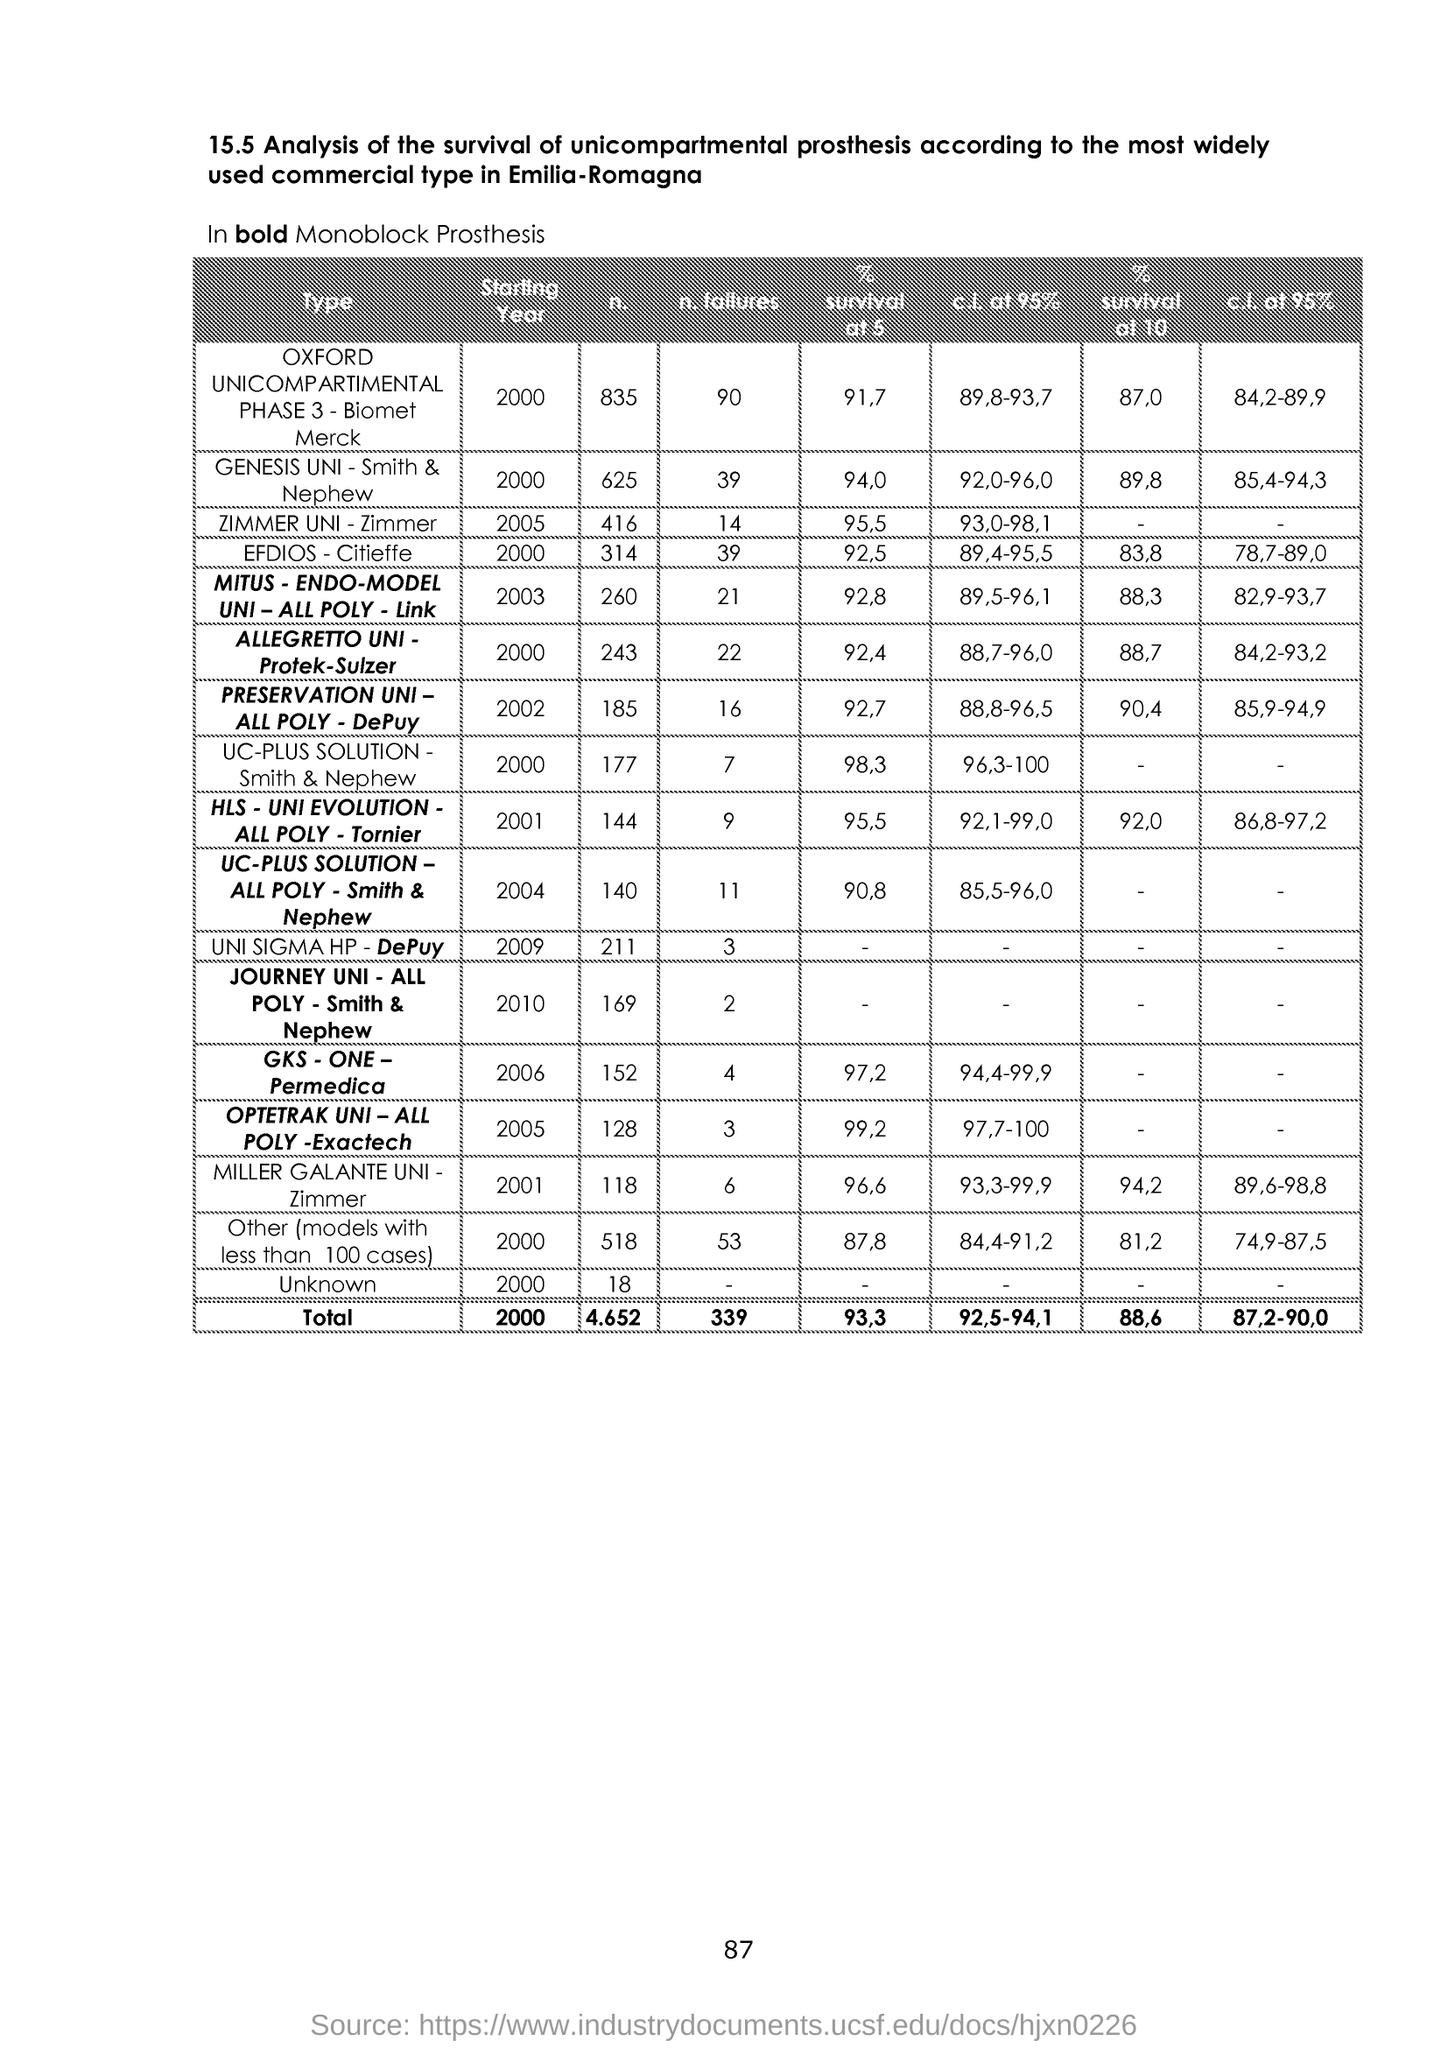What is the Page Number?
Your answer should be compact. 87. 